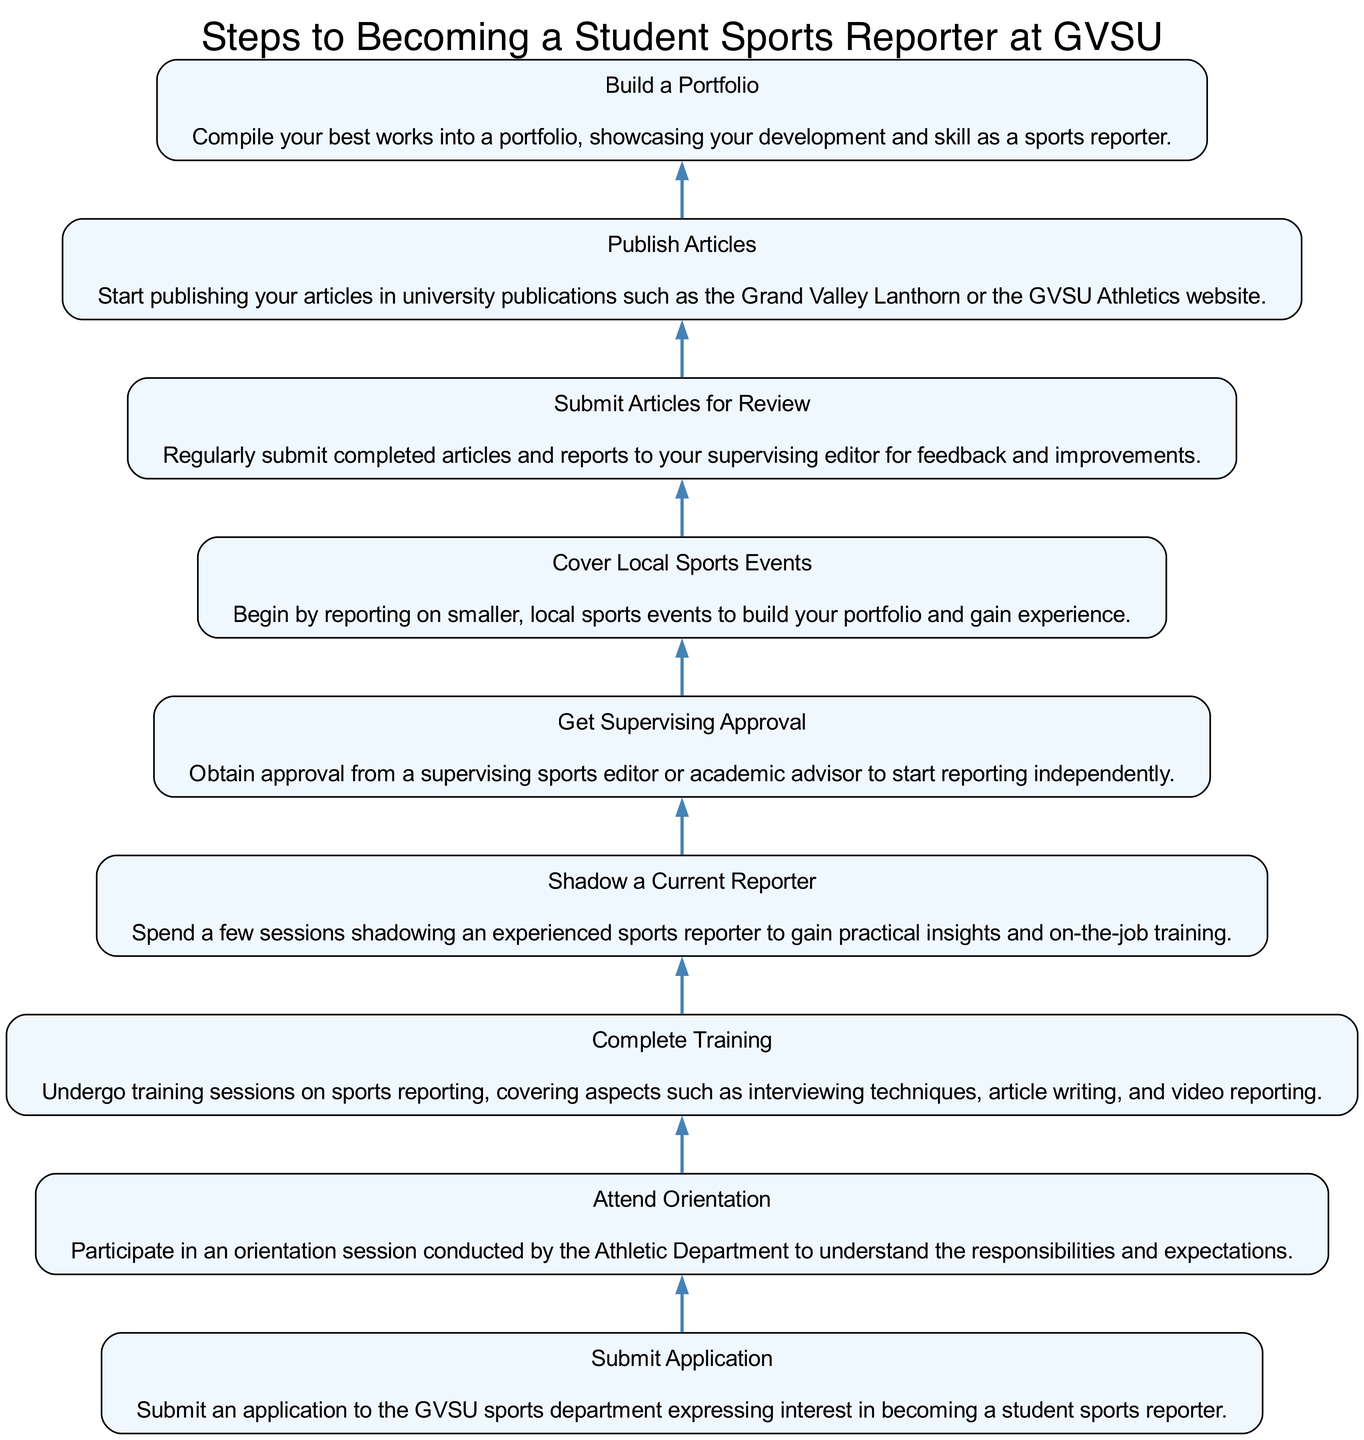What is the first step to becoming a student sports reporter? The first step in the flow chart is titled "Submit Application," which indicates that an application must be submitted to express interest in the role.
Answer: Submit Application How many steps are outlined in the diagram? By reviewing the flow chart, I count a total of eight steps listed, detailing the process to become a student sports reporter at GVSU.
Answer: Eight What is required before covering local sports events? The step "Get Supervising Approval" logically follows "Shadow a Current Reporter," which indicates that approval from a supervising editor is needed before one can start covering local sports events.
Answer: Get Supervising Approval Which step comes directly after attending orientation? According to the flow of the diagram, the step that follows "Attend Orientation" is "Complete Training." This shows that after orientation, training sessions on reporting are conducted.
Answer: Complete Training What do you need to do with the articles you write? The diagram indicates that after writing articles, they must be regularly submitted for review to the supervising editor for feedback and improvements.
Answer: Submit Articles for Review In what sequence do you build a portfolio? The flow chart details that the steps leading to building a portfolio require first publishing articles and then compiling them into a portfolio to showcase skills.
Answer: Publish Articles Which step involves shadowing? In the progression of steps, "Shadow a Current Reporter" is the specific step that involves spending time with an experienced reporter to gain insight into the job.
Answer: Shadow a Current Reporter What should follow after completing training? Following the "Complete Training" step, the next step in the diagram is "Shadow a Current Reporter," indicating that practical experience through shadowing is the next action.
Answer: Shadow a Current Reporter What is the main outcome of submitting articles for review? The diagram states that the main purpose of submitting articles for review is to receive feedback and improve one's writing, which is crucial for development as a sports reporter.
Answer: Feedback and improvements 